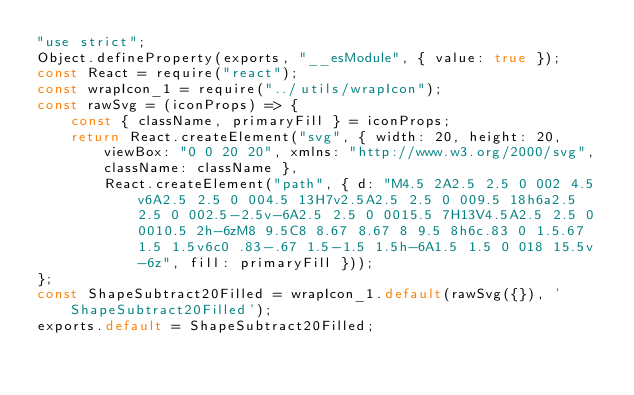<code> <loc_0><loc_0><loc_500><loc_500><_JavaScript_>"use strict";
Object.defineProperty(exports, "__esModule", { value: true });
const React = require("react");
const wrapIcon_1 = require("../utils/wrapIcon");
const rawSvg = (iconProps) => {
    const { className, primaryFill } = iconProps;
    return React.createElement("svg", { width: 20, height: 20, viewBox: "0 0 20 20", xmlns: "http://www.w3.org/2000/svg", className: className },
        React.createElement("path", { d: "M4.5 2A2.5 2.5 0 002 4.5v6A2.5 2.5 0 004.5 13H7v2.5A2.5 2.5 0 009.5 18h6a2.5 2.5 0 002.5-2.5v-6A2.5 2.5 0 0015.5 7H13V4.5A2.5 2.5 0 0010.5 2h-6zM8 9.5C8 8.67 8.67 8 9.5 8h6c.83 0 1.5.67 1.5 1.5v6c0 .83-.67 1.5-1.5 1.5h-6A1.5 1.5 0 018 15.5v-6z", fill: primaryFill }));
};
const ShapeSubtract20Filled = wrapIcon_1.default(rawSvg({}), 'ShapeSubtract20Filled');
exports.default = ShapeSubtract20Filled;
</code> 